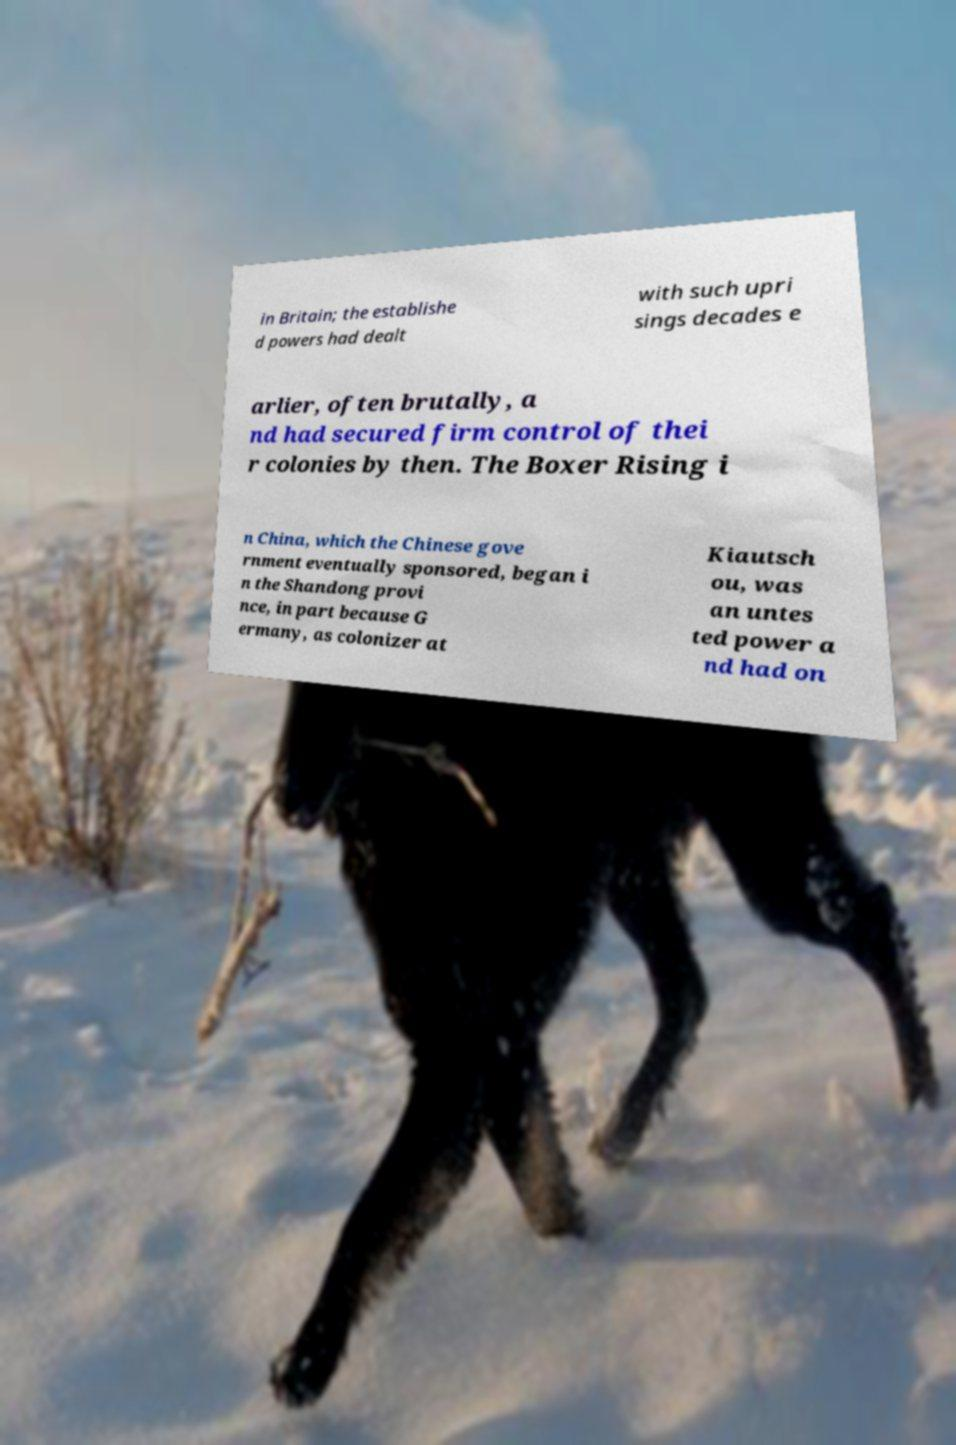Please read and relay the text visible in this image. What does it say? in Britain; the establishe d powers had dealt with such upri sings decades e arlier, often brutally, a nd had secured firm control of thei r colonies by then. The Boxer Rising i n China, which the Chinese gove rnment eventually sponsored, began i n the Shandong provi nce, in part because G ermany, as colonizer at Kiautsch ou, was an untes ted power a nd had on 